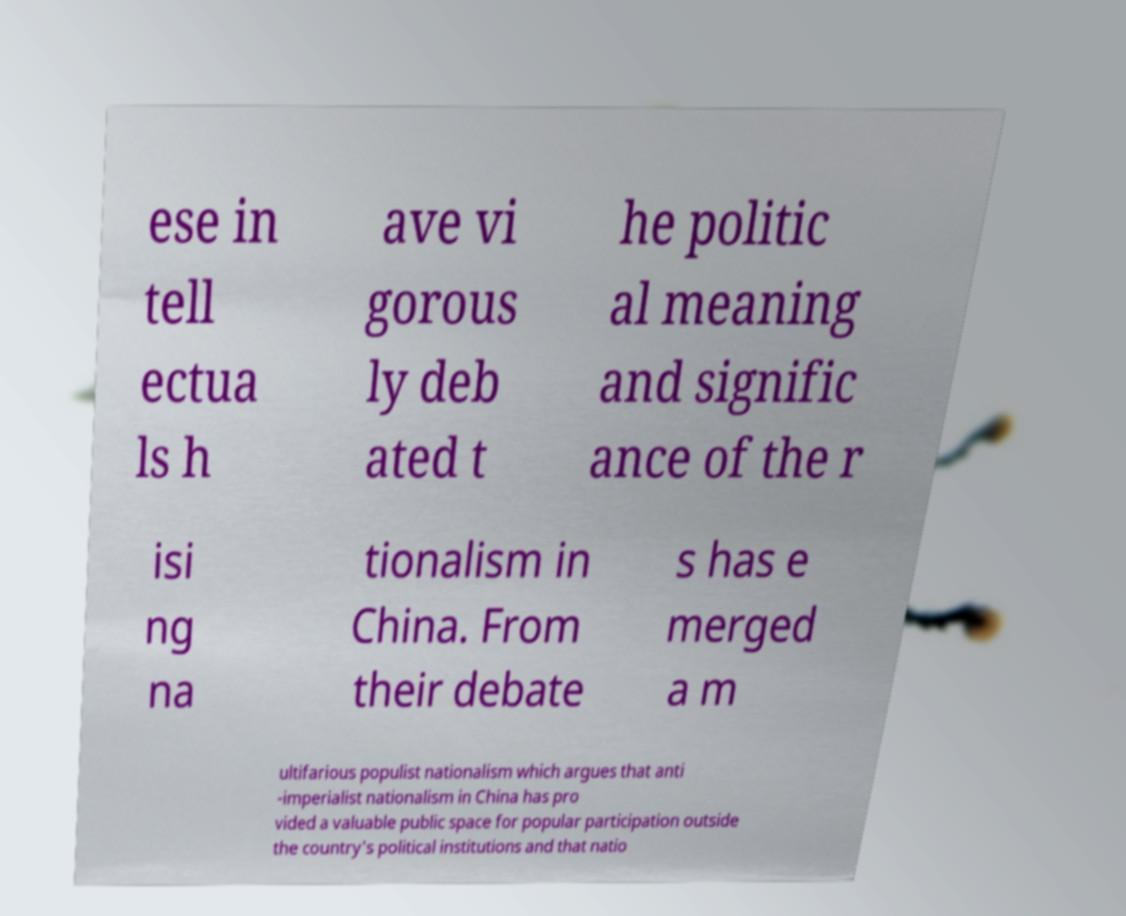Could you assist in decoding the text presented in this image and type it out clearly? ese in tell ectua ls h ave vi gorous ly deb ated t he politic al meaning and signific ance of the r isi ng na tionalism in China. From their debate s has e merged a m ultifarious populist nationalism which argues that anti -imperialist nationalism in China has pro vided a valuable public space for popular participation outside the country's political institutions and that natio 